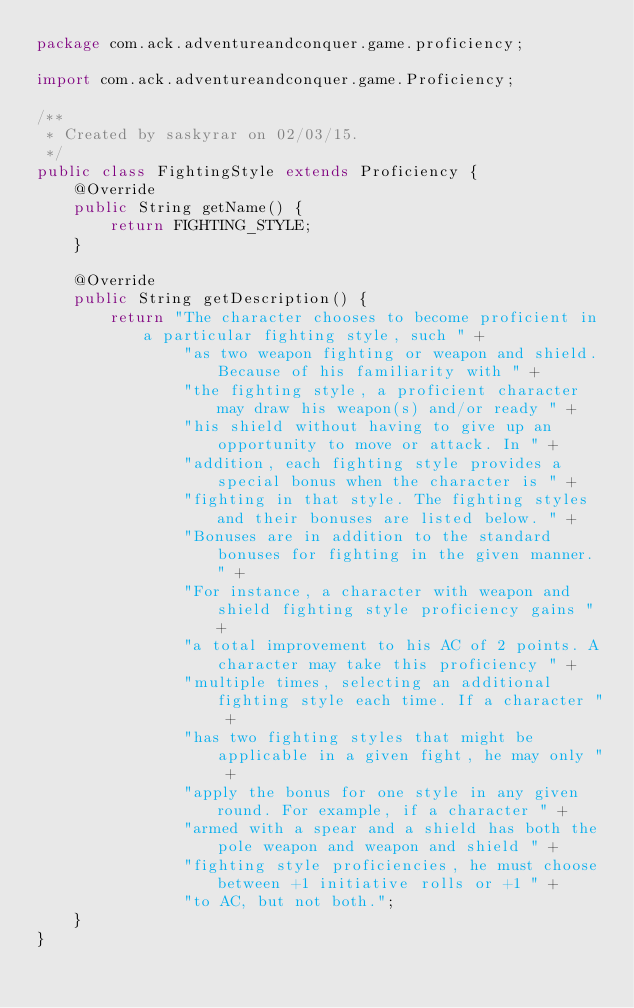Convert code to text. <code><loc_0><loc_0><loc_500><loc_500><_Java_>package com.ack.adventureandconquer.game.proficiency;

import com.ack.adventureandconquer.game.Proficiency;

/**
 * Created by saskyrar on 02/03/15.
 */
public class FightingStyle extends Proficiency {
    @Override
    public String getName() {
        return FIGHTING_STYLE;
    }

    @Override
    public String getDescription() {
        return "The character chooses to become proficient in a particular fighting style, such " +
                "as two weapon fighting or weapon and shield. Because of his familiarity with " +
                "the fighting style, a proficient character may draw his weapon(s) and/or ready " +
                "his shield without having to give up an opportunity to move or attack. In " +
                "addition, each fighting style provides a special bonus when the character is " +
                "fighting in that style. The fighting styles and their bonuses are listed below. " +
                "Bonuses are in addition to the standard bonuses for fighting in the given manner. " +
                "For instance, a character with weapon and shield fighting style proficiency gains " +
                "a total improvement to his AC of 2 points. A character may take this proficiency " +
                "multiple times, selecting an additional fighting style each time. If a character " +
                "has two fighting styles that might be applicable in a given fight, he may only " +
                "apply the bonus for one style in any given round. For example, if a character " +
                "armed with a spear and a shield has both the pole weapon and weapon and shield " +
                "fighting style proficiencies, he must choose between +1 initiative rolls or +1 " +
                "to AC, but not both.";
    }
}
</code> 